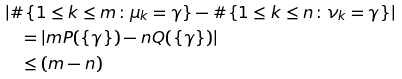<formula> <loc_0><loc_0><loc_500><loc_500>& \left | \# \{ 1 \leq k \leq m \colon \mu _ { k } = \gamma \} - \# \{ 1 \leq k \leq n \colon \nu _ { k } = \gamma \} \right | \\ & \quad = \left | m P ( \{ \gamma \} ) - n Q ( \{ \gamma \} ) \right | \\ & \quad \leq ( m - n ) \\</formula> 